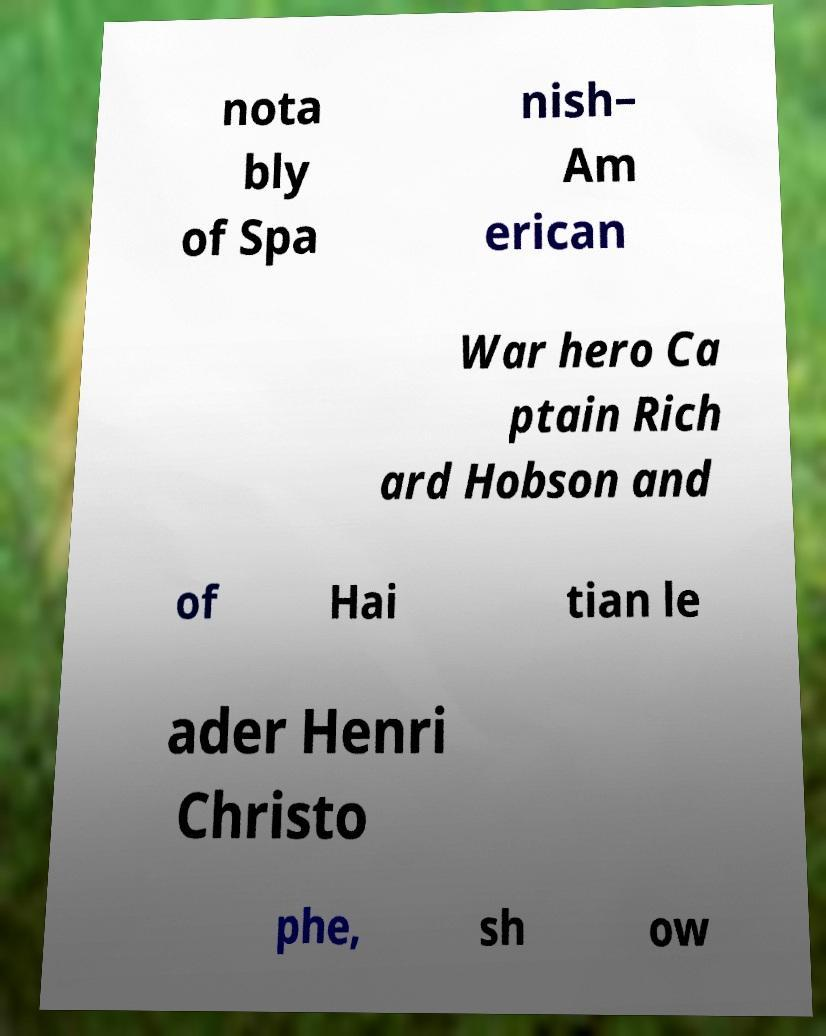Can you accurately transcribe the text from the provided image for me? nota bly of Spa nish– Am erican War hero Ca ptain Rich ard Hobson and of Hai tian le ader Henri Christo phe, sh ow 